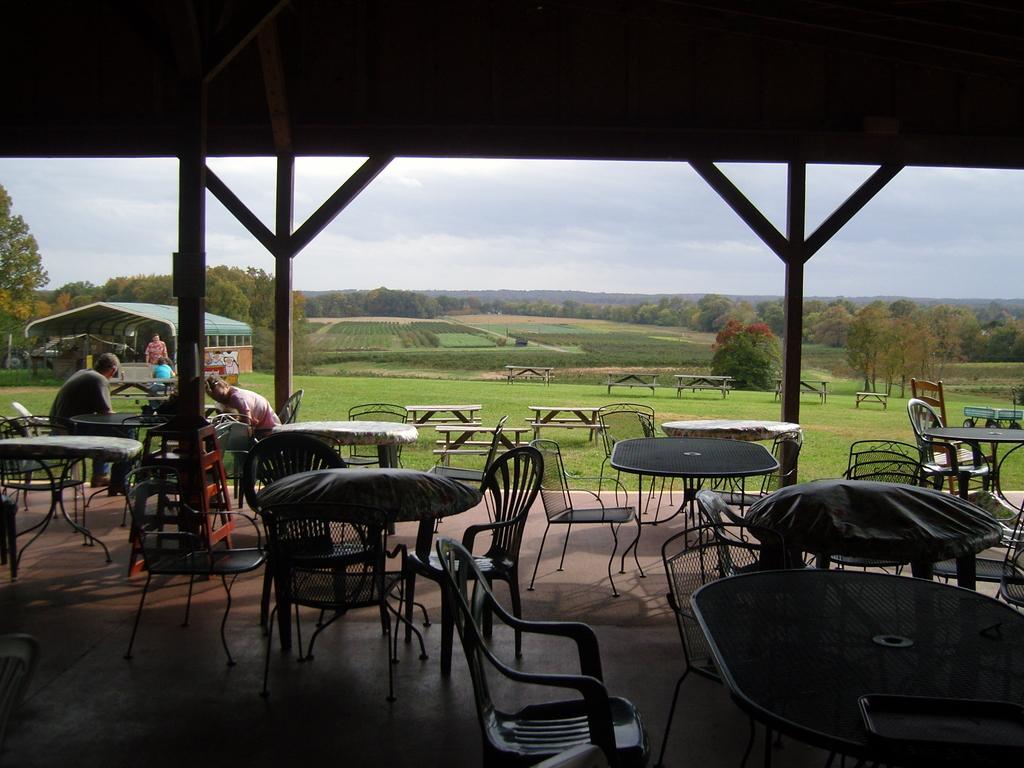In one or two sentences, can you explain what this image depicts? As we can see in the image there is a sky, tree, grass, chairs and tables and there are two people sitting on chairs. 